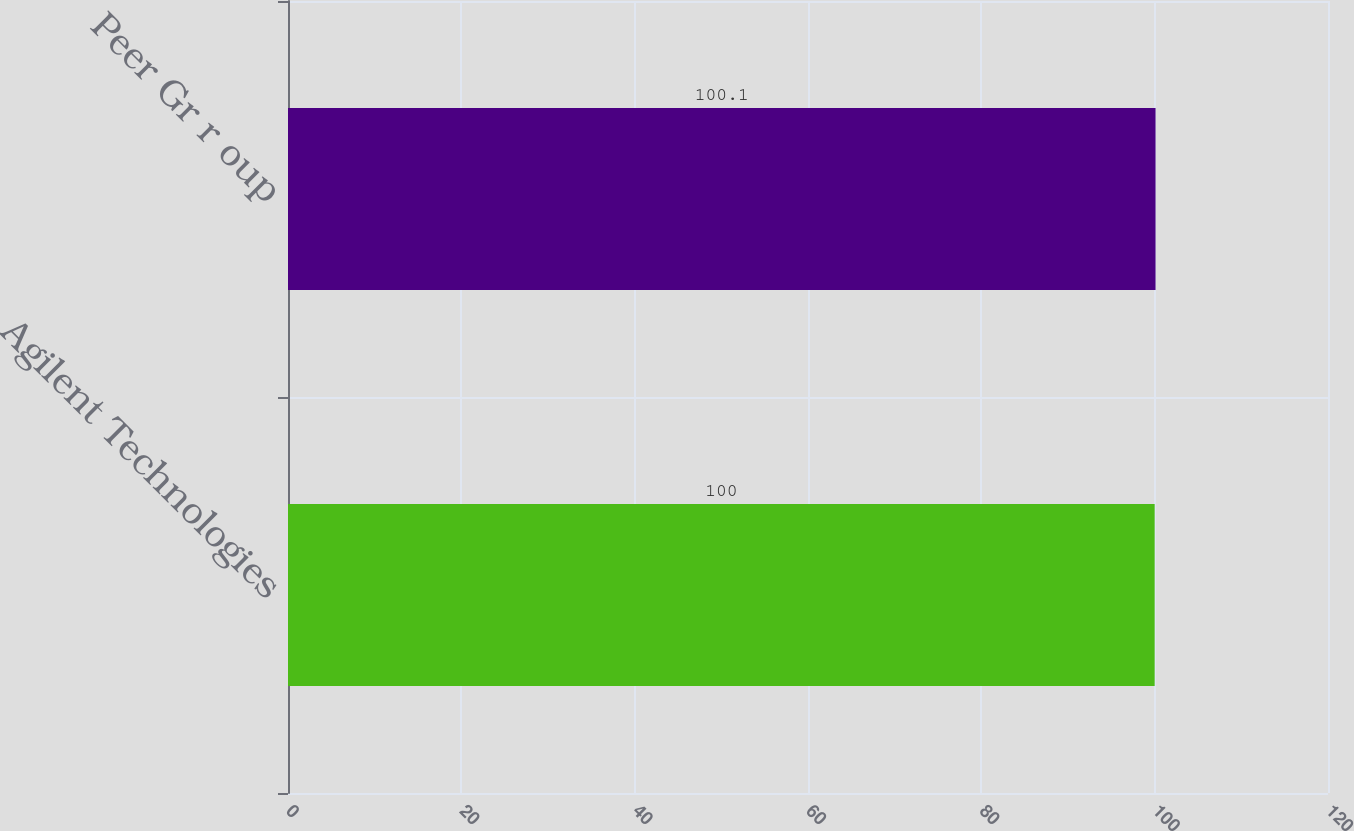Convert chart. <chart><loc_0><loc_0><loc_500><loc_500><bar_chart><fcel>Agilent Technologies<fcel>Peer Gr r oup<nl><fcel>100<fcel>100.1<nl></chart> 